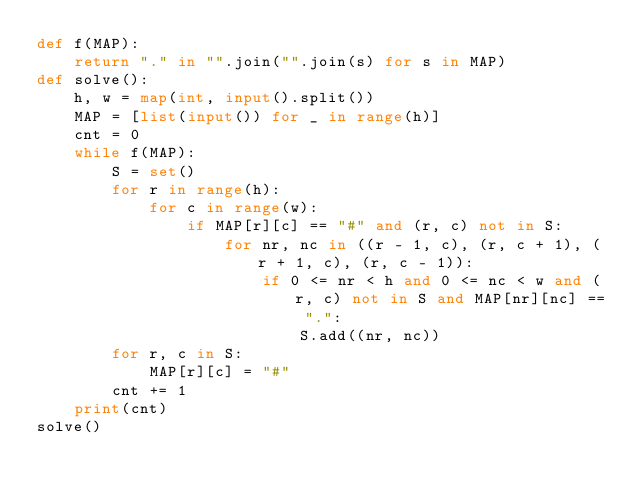<code> <loc_0><loc_0><loc_500><loc_500><_Python_>def f(MAP):
    return "." in "".join("".join(s) for s in MAP)
def solve():
    h, w = map(int, input().split())
    MAP = [list(input()) for _ in range(h)]
    cnt = 0
    while f(MAP):
        S = set()
        for r in range(h):
            for c in range(w):
                if MAP[r][c] == "#" and (r, c) not in S:
                    for nr, nc in ((r - 1, c), (r, c + 1), (r + 1, c), (r, c - 1)):
                        if 0 <= nr < h and 0 <= nc < w and (r, c) not in S and MAP[nr][nc] == ".":
                            S.add((nr, nc))
        for r, c in S:
            MAP[r][c] = "#"
        cnt += 1
    print(cnt)
solve()
</code> 